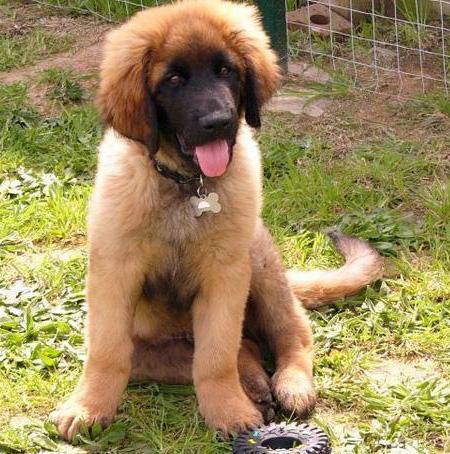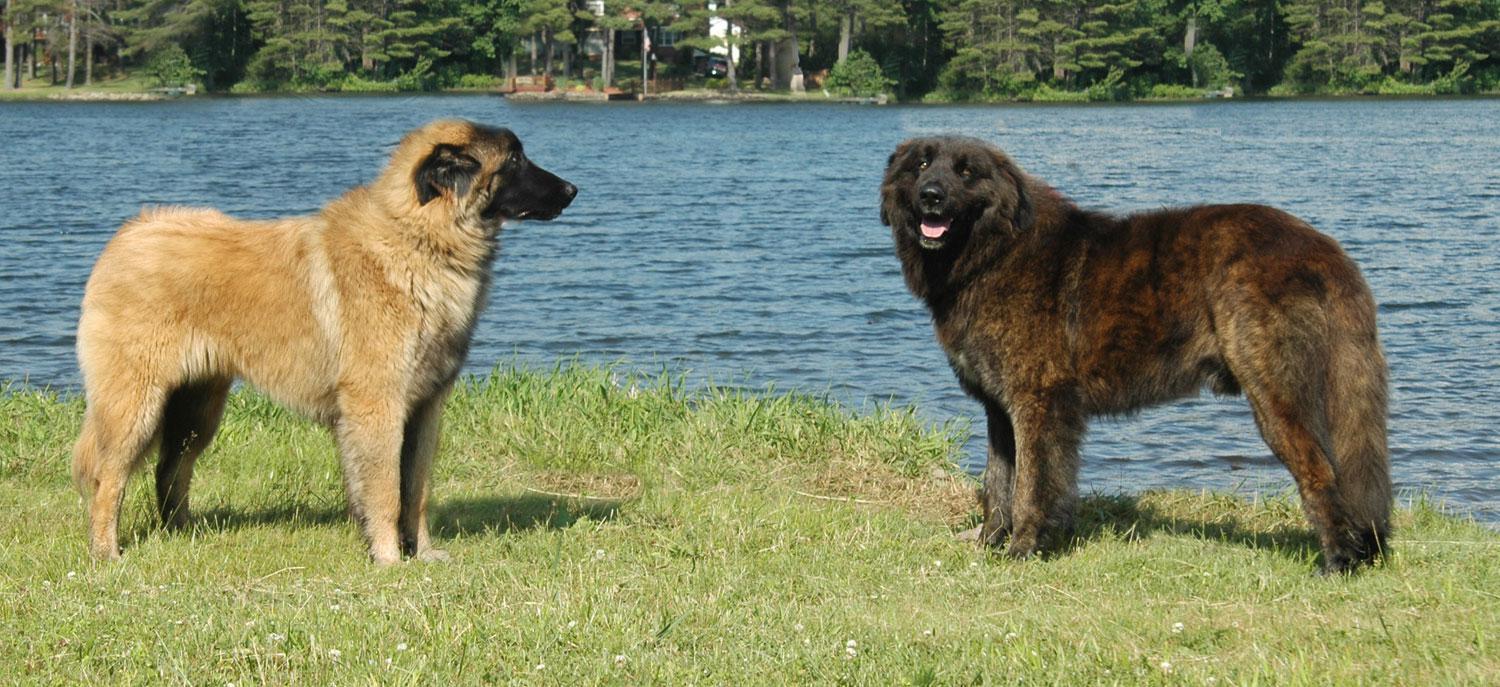The first image is the image on the left, the second image is the image on the right. Evaluate the accuracy of this statement regarding the images: "At least one human is pictured with dogs.". Is it true? Answer yes or no. No. 